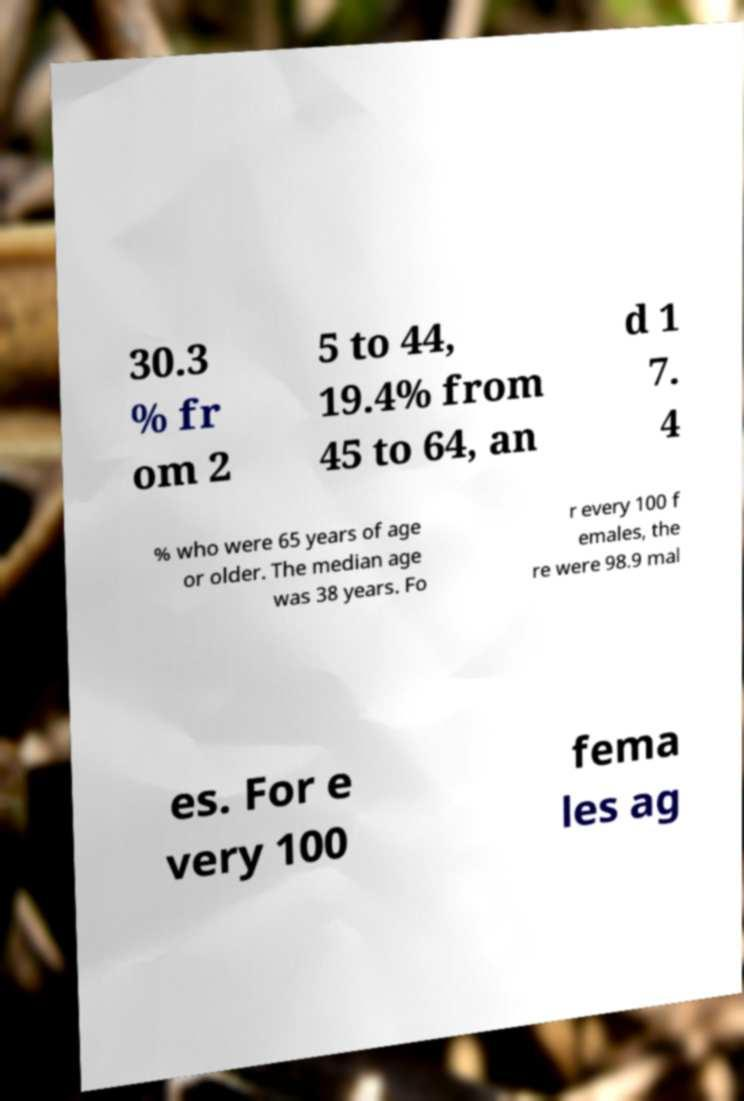Could you assist in decoding the text presented in this image and type it out clearly? 30.3 % fr om 2 5 to 44, 19.4% from 45 to 64, an d 1 7. 4 % who were 65 years of age or older. The median age was 38 years. Fo r every 100 f emales, the re were 98.9 mal es. For e very 100 fema les ag 